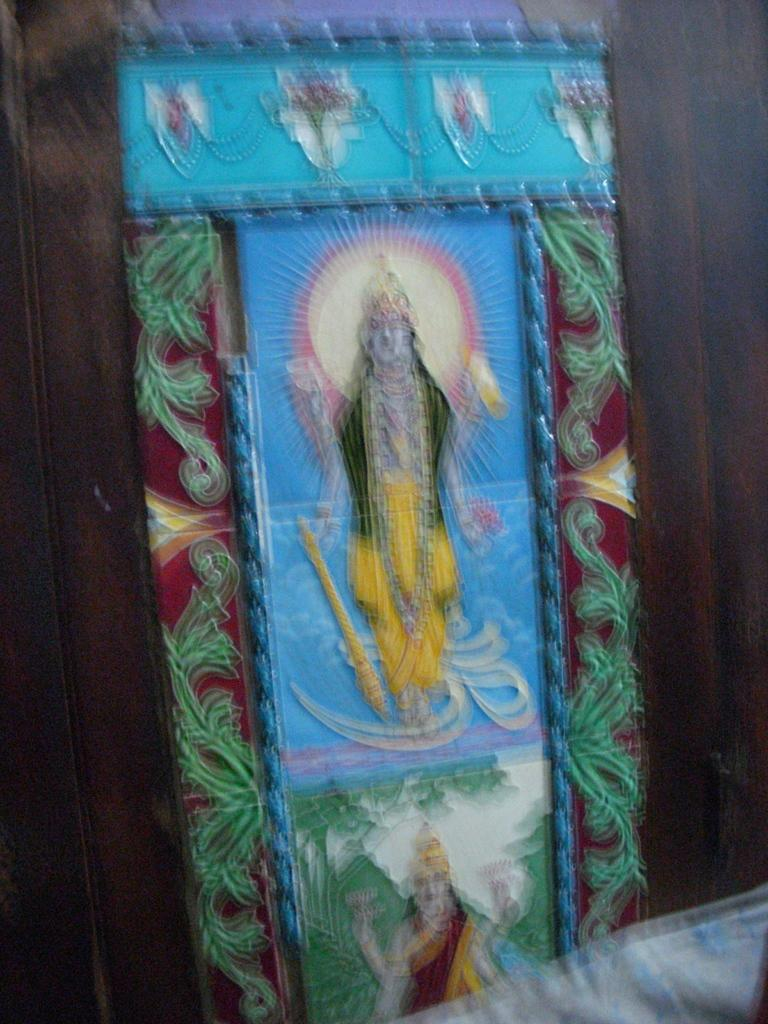What is the main subject of the image? The main subject of the image is a painting. What is depicted in the painting? The painting depicts a god and a goddess. What type of tail can be seen on the god in the painting? There is no tail visible on the god in the painting, as gods are typically depicted without tails. What offering is being made by the goddess in the painting? The image does not provide information about any offerings being made by the goddess in the painting. 